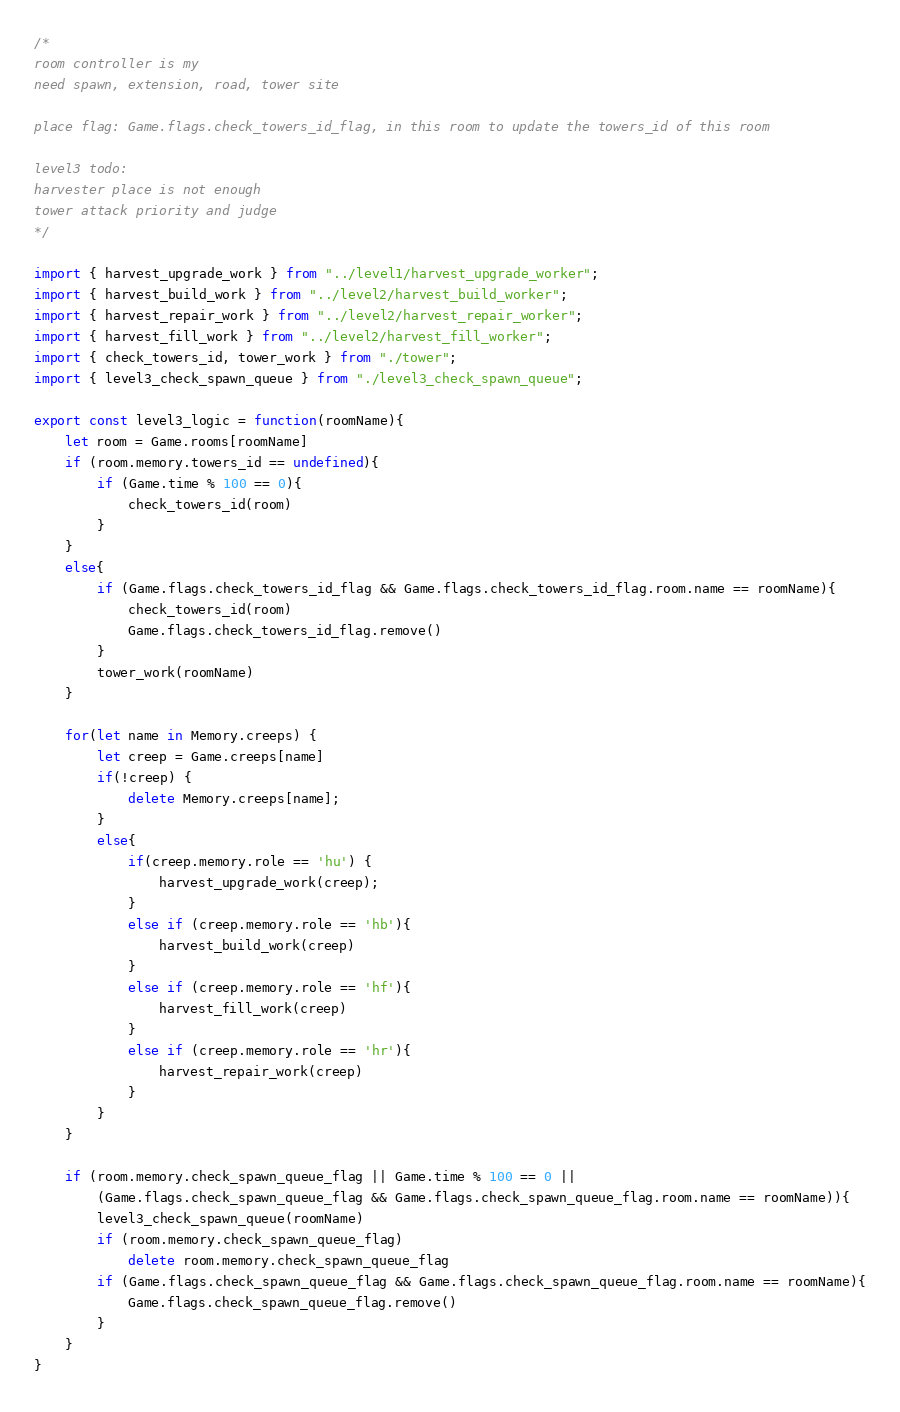<code> <loc_0><loc_0><loc_500><loc_500><_TypeScript_>/* 
room controller is my
need spawn, extension, road, tower site

place flag: Game.flags.check_towers_id_flag, in this room to update the towers_id of this room

level3 todo:
harvester place is not enough
tower attack priority and judge
*/

import { harvest_upgrade_work } from "../level1/harvest_upgrade_worker";
import { harvest_build_work } from "../level2/harvest_build_worker";
import { harvest_repair_work } from "../level2/harvest_repair_worker";
import { harvest_fill_work } from "../level2/harvest_fill_worker";
import { check_towers_id, tower_work } from "./tower";
import { level3_check_spawn_queue } from "./level3_check_spawn_queue";

export const level3_logic = function(roomName){
    let room = Game.rooms[roomName]
    if (room.memory.towers_id == undefined){
        if (Game.time % 100 == 0){
            check_towers_id(room)
        }
    }
    else{
        if (Game.flags.check_towers_id_flag && Game.flags.check_towers_id_flag.room.name == roomName){
            check_towers_id(room)
            Game.flags.check_towers_id_flag.remove()
        }
        tower_work(roomName)
    }

    for(let name in Memory.creeps) {
        let creep = Game.creeps[name]
        if(!creep) {
            delete Memory.creeps[name];
        }
        else{
            if(creep.memory.role == 'hu') {
                harvest_upgrade_work(creep);
            }
            else if (creep.memory.role == 'hb'){
                harvest_build_work(creep)
            }
            else if (creep.memory.role == 'hf'){
                harvest_fill_work(creep)
            }
            else if (creep.memory.role == 'hr'){
                harvest_repair_work(creep)
            }
        }
    }
    
    if (room.memory.check_spawn_queue_flag || Game.time % 100 == 0 ||
        (Game.flags.check_spawn_queue_flag && Game.flags.check_spawn_queue_flag.room.name == roomName)){
        level3_check_spawn_queue(roomName)
        if (room.memory.check_spawn_queue_flag)
            delete room.memory.check_spawn_queue_flag
        if (Game.flags.check_spawn_queue_flag && Game.flags.check_spawn_queue_flag.room.name == roomName){
            Game.flags.check_spawn_queue_flag.remove()
        }
    }
}</code> 